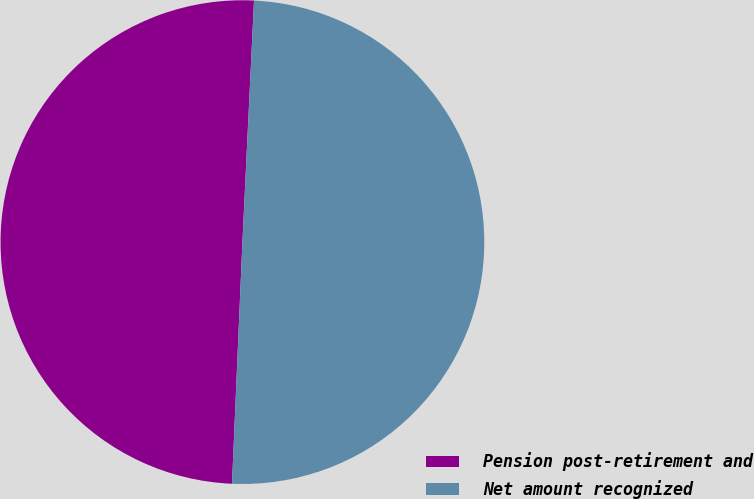<chart> <loc_0><loc_0><loc_500><loc_500><pie_chart><fcel>Pension post-retirement and<fcel>Net amount recognized<nl><fcel>50.08%<fcel>49.92%<nl></chart> 